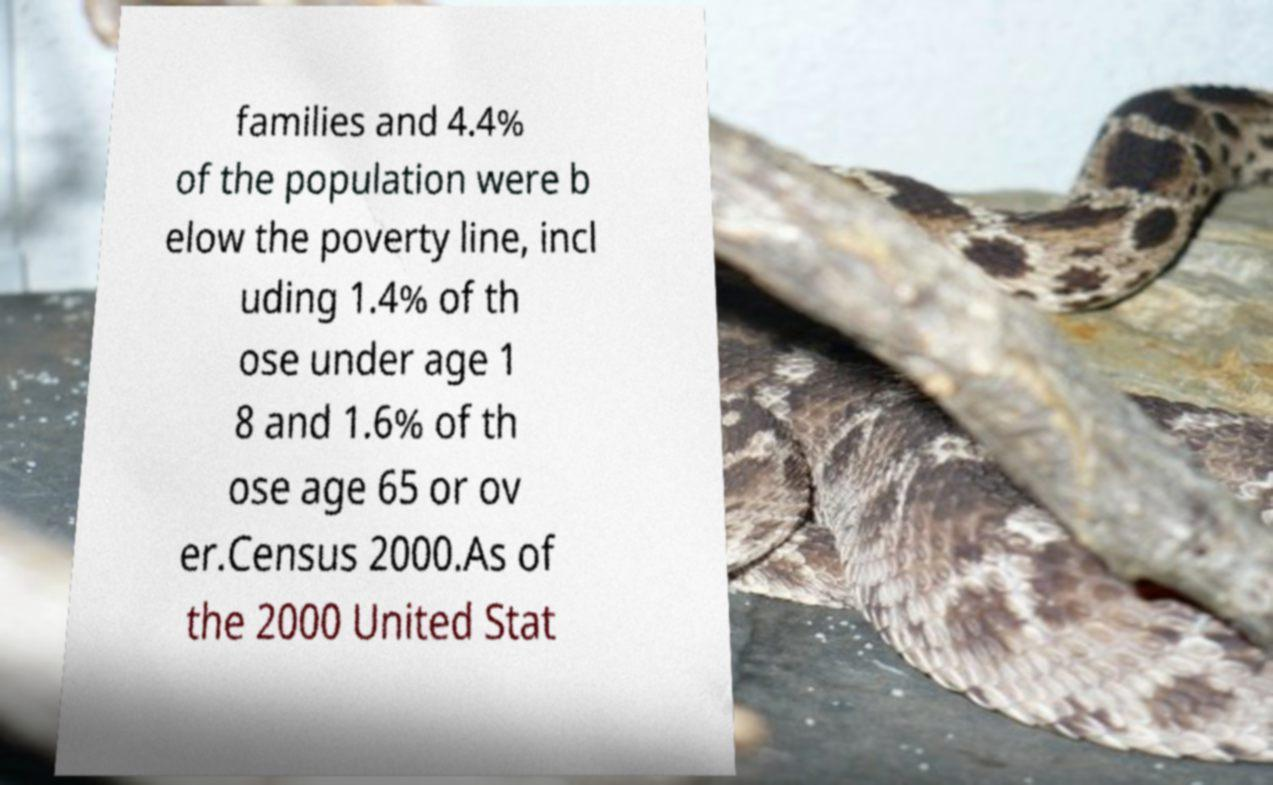Can you read and provide the text displayed in the image?This photo seems to have some interesting text. Can you extract and type it out for me? families and 4.4% of the population were b elow the poverty line, incl uding 1.4% of th ose under age 1 8 and 1.6% of th ose age 65 or ov er.Census 2000.As of the 2000 United Stat 